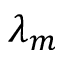Convert formula to latex. <formula><loc_0><loc_0><loc_500><loc_500>\lambda _ { m }</formula> 